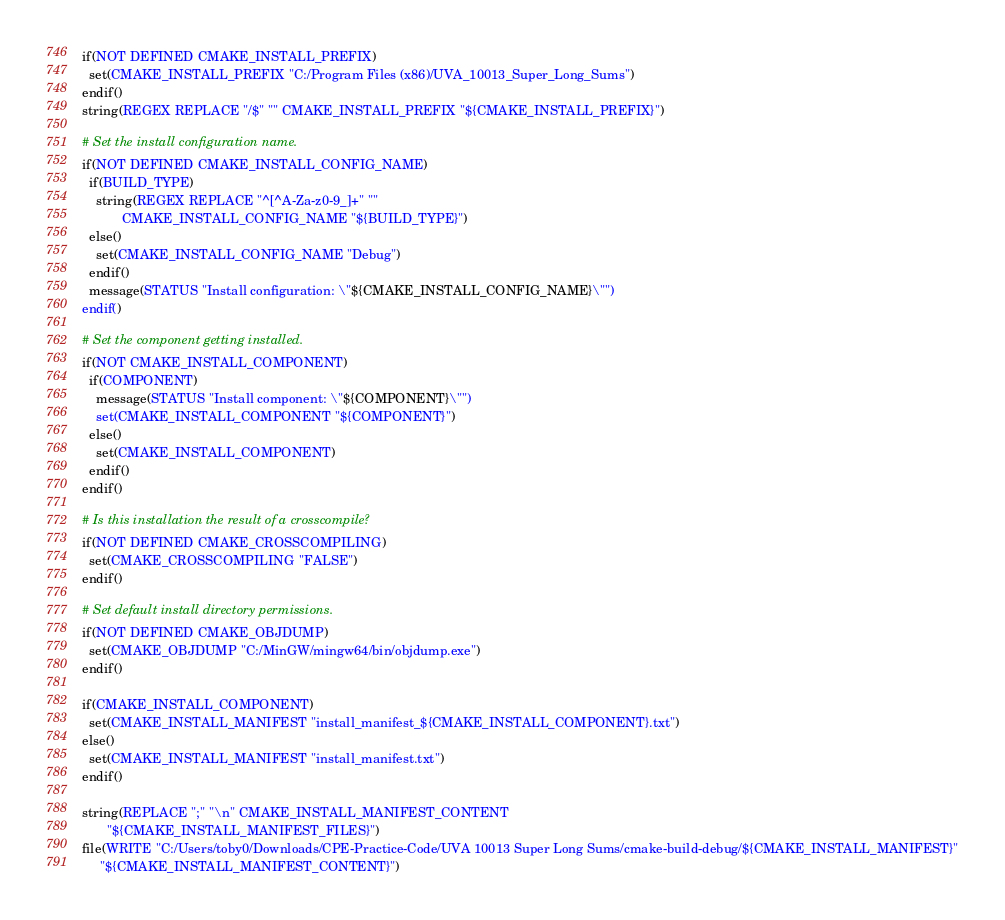<code> <loc_0><loc_0><loc_500><loc_500><_CMake_>if(NOT DEFINED CMAKE_INSTALL_PREFIX)
  set(CMAKE_INSTALL_PREFIX "C:/Program Files (x86)/UVA_10013_Super_Long_Sums")
endif()
string(REGEX REPLACE "/$" "" CMAKE_INSTALL_PREFIX "${CMAKE_INSTALL_PREFIX}")

# Set the install configuration name.
if(NOT DEFINED CMAKE_INSTALL_CONFIG_NAME)
  if(BUILD_TYPE)
    string(REGEX REPLACE "^[^A-Za-z0-9_]+" ""
           CMAKE_INSTALL_CONFIG_NAME "${BUILD_TYPE}")
  else()
    set(CMAKE_INSTALL_CONFIG_NAME "Debug")
  endif()
  message(STATUS "Install configuration: \"${CMAKE_INSTALL_CONFIG_NAME}\"")
endif()

# Set the component getting installed.
if(NOT CMAKE_INSTALL_COMPONENT)
  if(COMPONENT)
    message(STATUS "Install component: \"${COMPONENT}\"")
    set(CMAKE_INSTALL_COMPONENT "${COMPONENT}")
  else()
    set(CMAKE_INSTALL_COMPONENT)
  endif()
endif()

# Is this installation the result of a crosscompile?
if(NOT DEFINED CMAKE_CROSSCOMPILING)
  set(CMAKE_CROSSCOMPILING "FALSE")
endif()

# Set default install directory permissions.
if(NOT DEFINED CMAKE_OBJDUMP)
  set(CMAKE_OBJDUMP "C:/MinGW/mingw64/bin/objdump.exe")
endif()

if(CMAKE_INSTALL_COMPONENT)
  set(CMAKE_INSTALL_MANIFEST "install_manifest_${CMAKE_INSTALL_COMPONENT}.txt")
else()
  set(CMAKE_INSTALL_MANIFEST "install_manifest.txt")
endif()

string(REPLACE ";" "\n" CMAKE_INSTALL_MANIFEST_CONTENT
       "${CMAKE_INSTALL_MANIFEST_FILES}")
file(WRITE "C:/Users/toby0/Downloads/CPE-Practice-Code/UVA 10013 Super Long Sums/cmake-build-debug/${CMAKE_INSTALL_MANIFEST}"
     "${CMAKE_INSTALL_MANIFEST_CONTENT}")
</code> 